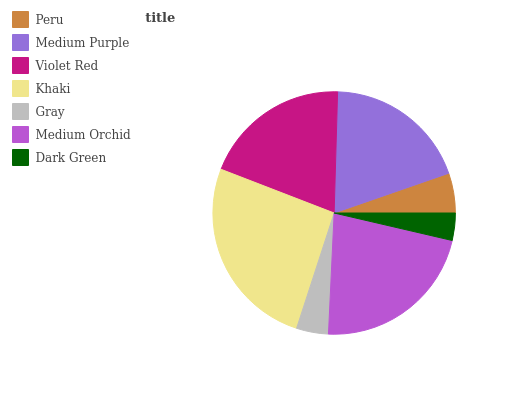Is Dark Green the minimum?
Answer yes or no. Yes. Is Khaki the maximum?
Answer yes or no. Yes. Is Medium Purple the minimum?
Answer yes or no. No. Is Medium Purple the maximum?
Answer yes or no. No. Is Medium Purple greater than Peru?
Answer yes or no. Yes. Is Peru less than Medium Purple?
Answer yes or no. Yes. Is Peru greater than Medium Purple?
Answer yes or no. No. Is Medium Purple less than Peru?
Answer yes or no. No. Is Medium Purple the high median?
Answer yes or no. Yes. Is Medium Purple the low median?
Answer yes or no. Yes. Is Dark Green the high median?
Answer yes or no. No. Is Medium Orchid the low median?
Answer yes or no. No. 